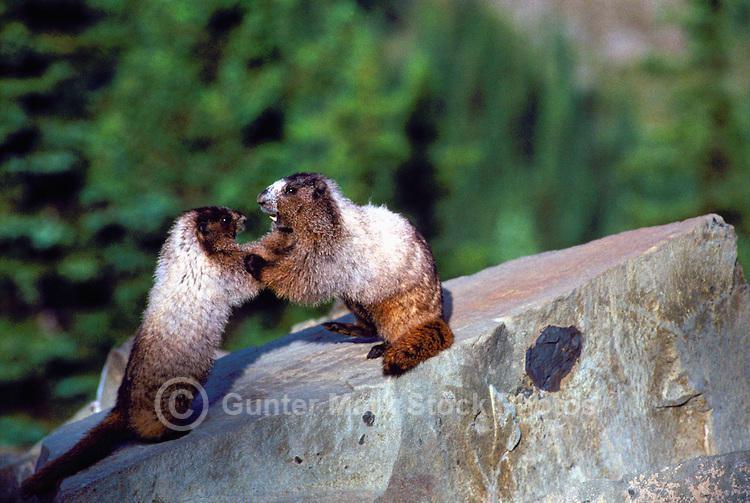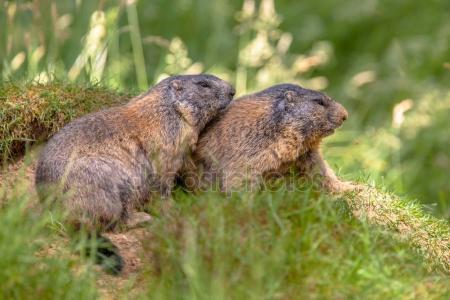The first image is the image on the left, the second image is the image on the right. Assess this claim about the two images: "There are two rodents in the right image that are facing towards the right.". Correct or not? Answer yes or no. Yes. 